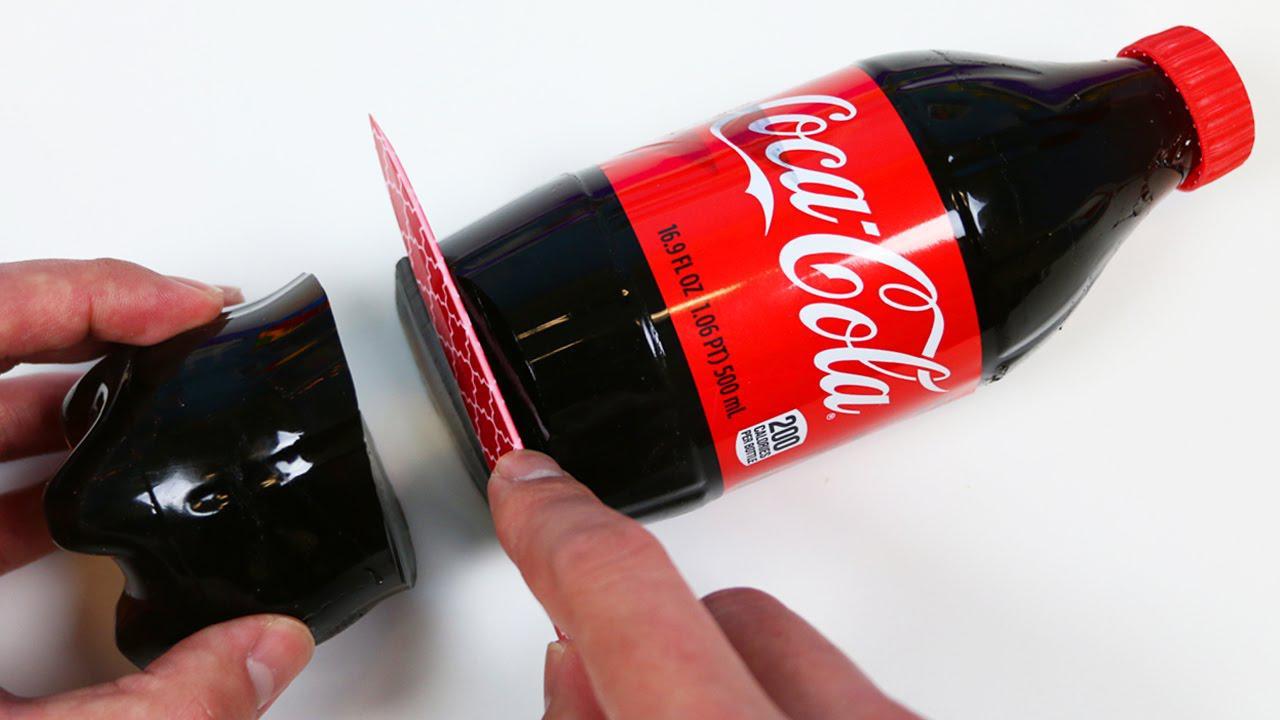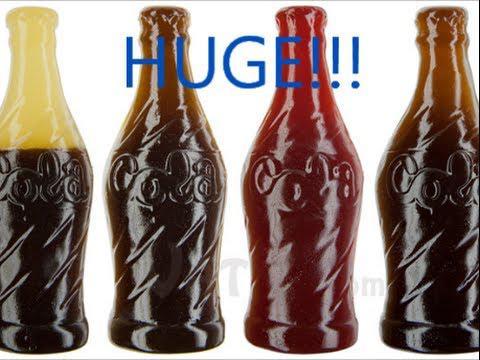The first image is the image on the left, the second image is the image on the right. Analyze the images presented: Is the assertion "One image includes a silver-bladed knife and a bottle shape that is cut in two separated parts, and a hand is grasping a bottle that is not split in two parts in the other image." valid? Answer yes or no. No. The first image is the image on the left, the second image is the image on the right. Analyze the images presented: Is the assertion "One of the gummy sodas is orange." valid? Answer yes or no. No. 